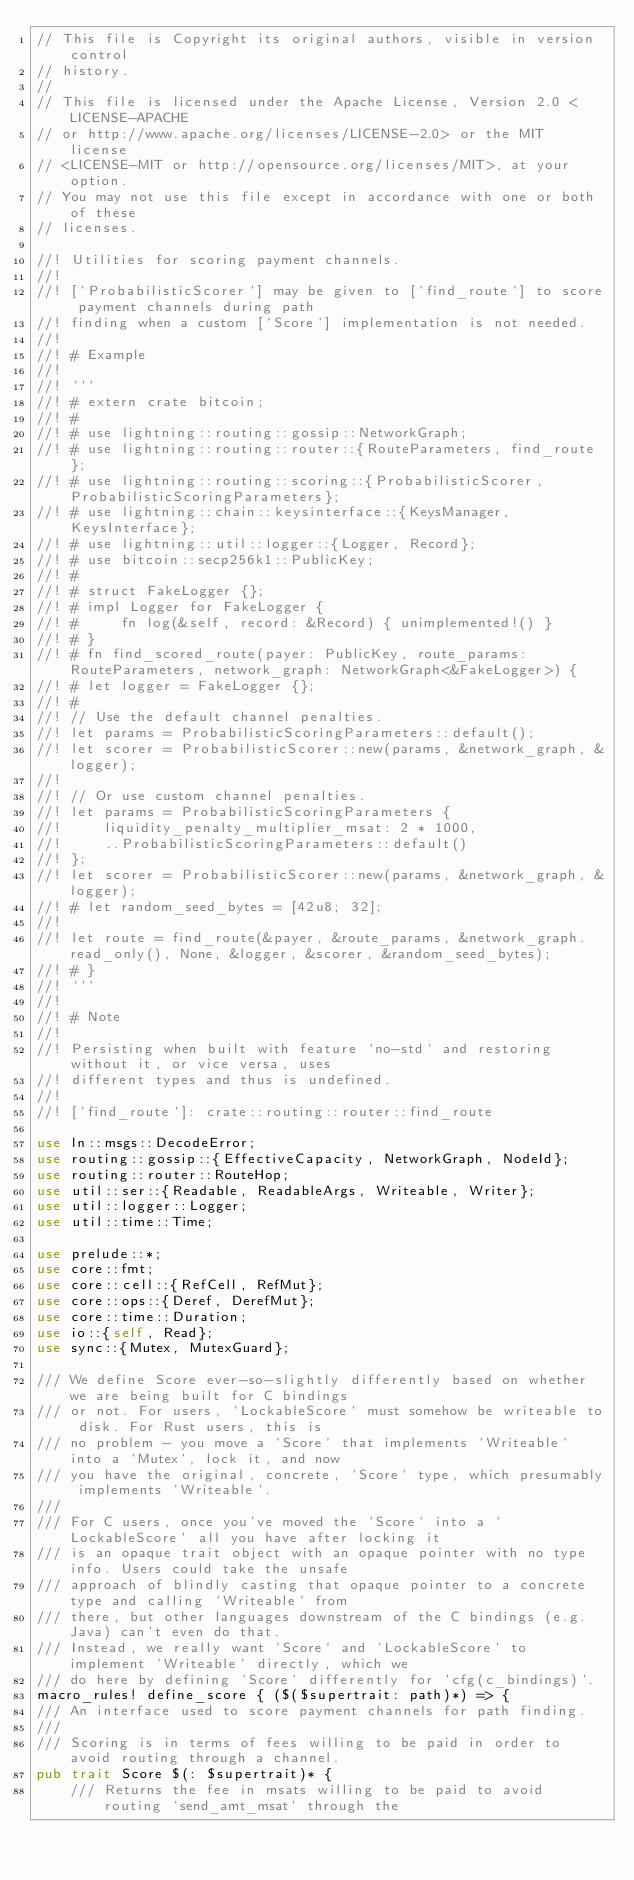Convert code to text. <code><loc_0><loc_0><loc_500><loc_500><_Rust_>// This file is Copyright its original authors, visible in version control
// history.
//
// This file is licensed under the Apache License, Version 2.0 <LICENSE-APACHE
// or http://www.apache.org/licenses/LICENSE-2.0> or the MIT license
// <LICENSE-MIT or http://opensource.org/licenses/MIT>, at your option.
// You may not use this file except in accordance with one or both of these
// licenses.

//! Utilities for scoring payment channels.
//!
//! [`ProbabilisticScorer`] may be given to [`find_route`] to score payment channels during path
//! finding when a custom [`Score`] implementation is not needed.
//!
//! # Example
//!
//! ```
//! # extern crate bitcoin;
//! #
//! # use lightning::routing::gossip::NetworkGraph;
//! # use lightning::routing::router::{RouteParameters, find_route};
//! # use lightning::routing::scoring::{ProbabilisticScorer, ProbabilisticScoringParameters};
//! # use lightning::chain::keysinterface::{KeysManager, KeysInterface};
//! # use lightning::util::logger::{Logger, Record};
//! # use bitcoin::secp256k1::PublicKey;
//! #
//! # struct FakeLogger {};
//! # impl Logger for FakeLogger {
//! #     fn log(&self, record: &Record) { unimplemented!() }
//! # }
//! # fn find_scored_route(payer: PublicKey, route_params: RouteParameters, network_graph: NetworkGraph<&FakeLogger>) {
//! # let logger = FakeLogger {};
//! #
//! // Use the default channel penalties.
//! let params = ProbabilisticScoringParameters::default();
//! let scorer = ProbabilisticScorer::new(params, &network_graph, &logger);
//!
//! // Or use custom channel penalties.
//! let params = ProbabilisticScoringParameters {
//!     liquidity_penalty_multiplier_msat: 2 * 1000,
//!     ..ProbabilisticScoringParameters::default()
//! };
//! let scorer = ProbabilisticScorer::new(params, &network_graph, &logger);
//! # let random_seed_bytes = [42u8; 32];
//!
//! let route = find_route(&payer, &route_params, &network_graph.read_only(), None, &logger, &scorer, &random_seed_bytes);
//! # }
//! ```
//!
//! # Note
//!
//! Persisting when built with feature `no-std` and restoring without it, or vice versa, uses
//! different types and thus is undefined.
//!
//! [`find_route`]: crate::routing::router::find_route

use ln::msgs::DecodeError;
use routing::gossip::{EffectiveCapacity, NetworkGraph, NodeId};
use routing::router::RouteHop;
use util::ser::{Readable, ReadableArgs, Writeable, Writer};
use util::logger::Logger;
use util::time::Time;

use prelude::*;
use core::fmt;
use core::cell::{RefCell, RefMut};
use core::ops::{Deref, DerefMut};
use core::time::Duration;
use io::{self, Read};
use sync::{Mutex, MutexGuard};

/// We define Score ever-so-slightly differently based on whether we are being built for C bindings
/// or not. For users, `LockableScore` must somehow be writeable to disk. For Rust users, this is
/// no problem - you move a `Score` that implements `Writeable` into a `Mutex`, lock it, and now
/// you have the original, concrete, `Score` type, which presumably implements `Writeable`.
///
/// For C users, once you've moved the `Score` into a `LockableScore` all you have after locking it
/// is an opaque trait object with an opaque pointer with no type info. Users could take the unsafe
/// approach of blindly casting that opaque pointer to a concrete type and calling `Writeable` from
/// there, but other languages downstream of the C bindings (e.g. Java) can't even do that.
/// Instead, we really want `Score` and `LockableScore` to implement `Writeable` directly, which we
/// do here by defining `Score` differently for `cfg(c_bindings)`.
macro_rules! define_score { ($($supertrait: path)*) => {
/// An interface used to score payment channels for path finding.
///
///	Scoring is in terms of fees willing to be paid in order to avoid routing through a channel.
pub trait Score $(: $supertrait)* {
	/// Returns the fee in msats willing to be paid to avoid routing `send_amt_msat` through the</code> 